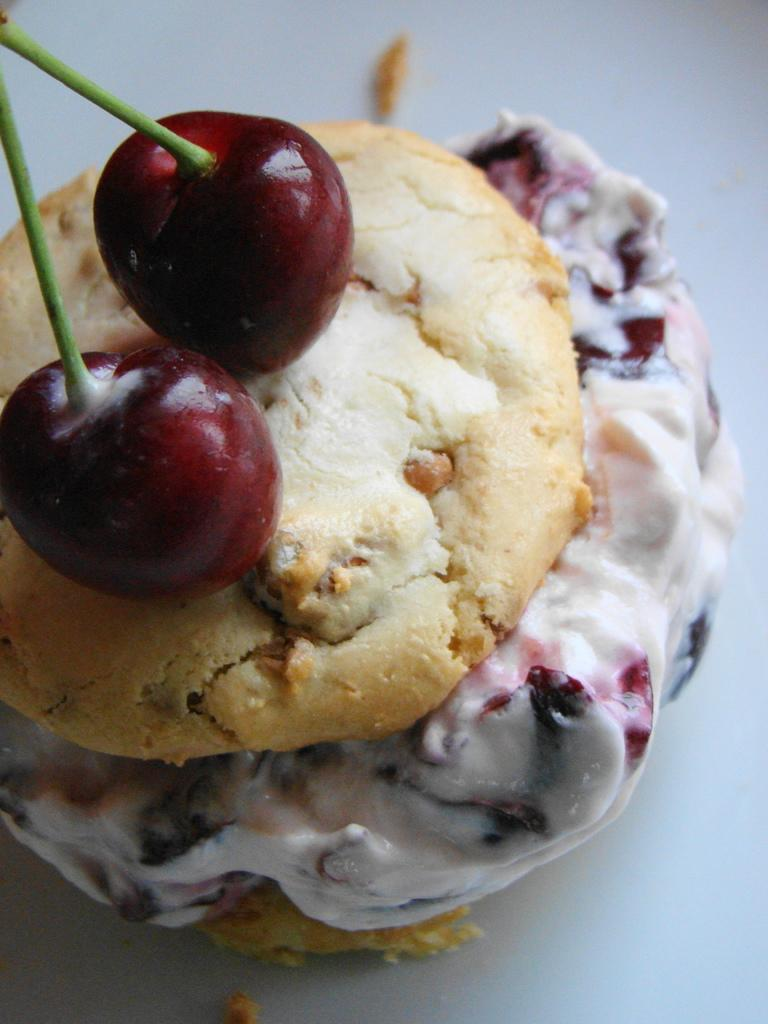What type of fruit is present in the image? There are two cherries with stems in the image. What is the cherries placed on? The cherries are placed on a food item. What is the color of the background in the image? The background in the image is white. How many bikes can be seen in the image? There are no bikes present in the image. What type of art is displayed in the image? There is no art displayed in the image; it features cherries on a food item with a white background. 